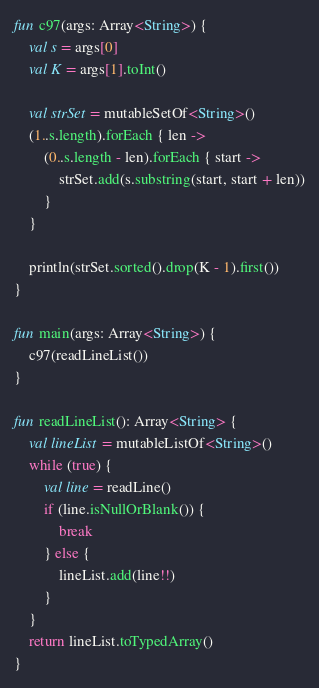<code> <loc_0><loc_0><loc_500><loc_500><_Kotlin_>fun c97(args: Array<String>) {
    val s = args[0]
    val K = args[1].toInt()

    val strSet = mutableSetOf<String>()
    (1..s.length).forEach { len ->
        (0..s.length - len).forEach { start ->
            strSet.add(s.substring(start, start + len))
        }
    }

    println(strSet.sorted().drop(K - 1).first())
}

fun main(args: Array<String>) {
    c97(readLineList())
}

fun readLineList(): Array<String> {
    val lineList = mutableListOf<String>()
    while (true) {
        val line = readLine()
        if (line.isNullOrBlank()) {
            break
        } else {
            lineList.add(line!!)
        }
    }
    return lineList.toTypedArray()
}</code> 